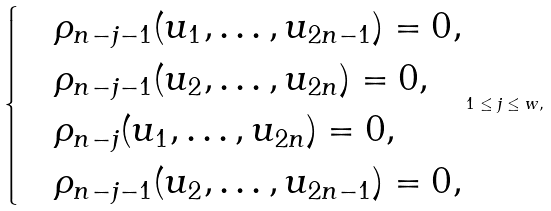<formula> <loc_0><loc_0><loc_500><loc_500>\begin{cases} & \rho _ { n - j - 1 } ( u _ { 1 } , \dots , u _ { 2 n - 1 } ) = 0 , \\ & \rho _ { n - j - 1 } ( u _ { 2 } , \dots , u _ { 2 n } ) = 0 , \\ & \rho _ { n - j } ( u _ { 1 } , \dots , u _ { 2 n } ) = 0 , \\ & \rho _ { n - j - 1 } ( u _ { 2 } , \dots , u _ { 2 n - 1 } ) = 0 , \end{cases} 1 \leq j \leq w ,</formula> 